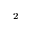<formula> <loc_0><loc_0><loc_500><loc_500>_ { 2 }</formula> 